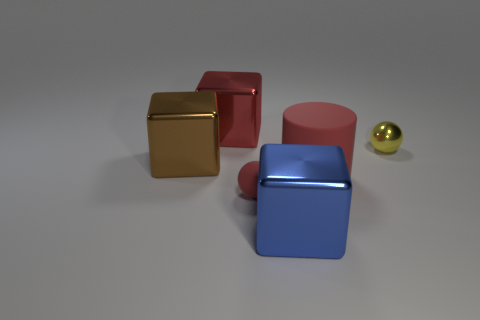The metal thing that is the same color as the big cylinder is what shape?
Give a very brief answer. Cube. Do the red object behind the rubber cylinder and the red matte thing in front of the matte cylinder have the same shape?
Provide a succinct answer. No. Are there any yellow balls in front of the small yellow object that is behind the brown block?
Ensure brevity in your answer.  No. Are there any red rubber objects?
Ensure brevity in your answer.  Yes. How many cyan rubber cylinders are the same size as the red cube?
Keep it short and to the point. 0. How many red things are left of the blue shiny object and in front of the brown shiny object?
Make the answer very short. 1. Is the size of the ball that is to the right of the blue metallic block the same as the matte cylinder?
Provide a short and direct response. No. Are there any large metallic objects of the same color as the small rubber object?
Your answer should be compact. Yes. What size is the red cube that is made of the same material as the big brown thing?
Your answer should be compact. Large. Is the number of red blocks that are behind the small yellow sphere greater than the number of red matte cylinders behind the red metallic block?
Provide a succinct answer. Yes. 